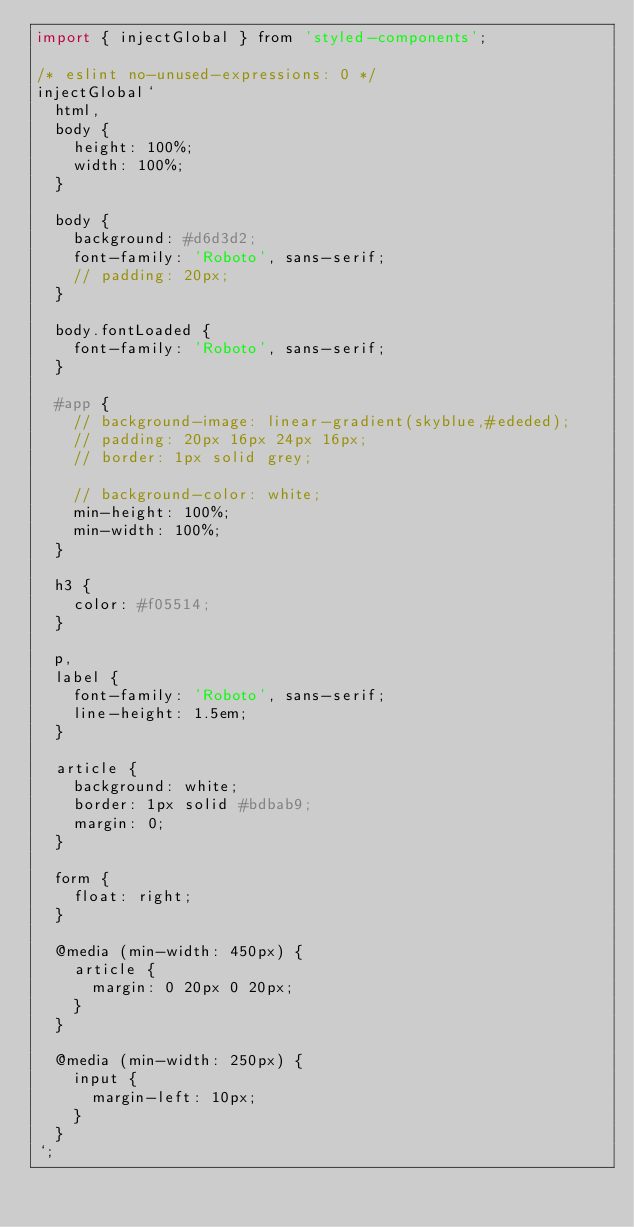Convert code to text. <code><loc_0><loc_0><loc_500><loc_500><_JavaScript_>import { injectGlobal } from 'styled-components';

/* eslint no-unused-expressions: 0 */
injectGlobal`
  html,
  body {
    height: 100%;
    width: 100%;
  }

  body {
    background: #d6d3d2;
    font-family: 'Roboto', sans-serif;
    // padding: 20px;
  }

  body.fontLoaded {
    font-family: 'Roboto', sans-serif;
  }

  #app {
    // background-image: linear-gradient(skyblue,#ededed);
    // padding: 20px 16px 24px 16px;
    // border: 1px solid grey;
    
    // background-color: white;
    min-height: 100%;
    min-width: 100%;
  }
  
  h3 {
    color: #f05514;
  }

  p,
  label {
    font-family: 'Roboto', sans-serif;
    line-height: 1.5em;
  }
  
  article {
    background: white;
    border: 1px solid #bdbab9;
    margin: 0;
  }
  
  form {
    float: right;
  }
  
  @media (min-width: 450px) {
    article {
      margin: 0 20px 0 20px;
    }
  }
  
  @media (min-width: 250px) {
    input {
      margin-left: 10px;
    }
  }
`;
</code> 